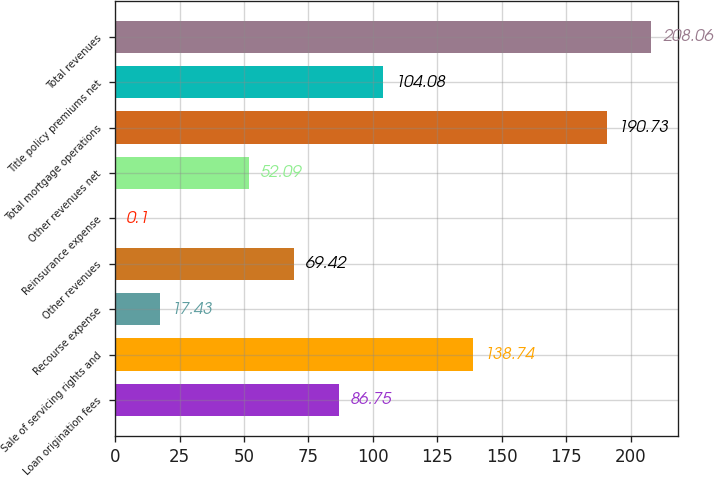<chart> <loc_0><loc_0><loc_500><loc_500><bar_chart><fcel>Loan origination fees<fcel>Sale of servicing rights and<fcel>Recourse expense<fcel>Other revenues<fcel>Reinsurance expense<fcel>Other revenues net<fcel>Total mortgage operations<fcel>Title policy premiums net<fcel>Total revenues<nl><fcel>86.75<fcel>138.74<fcel>17.43<fcel>69.42<fcel>0.1<fcel>52.09<fcel>190.73<fcel>104.08<fcel>208.06<nl></chart> 